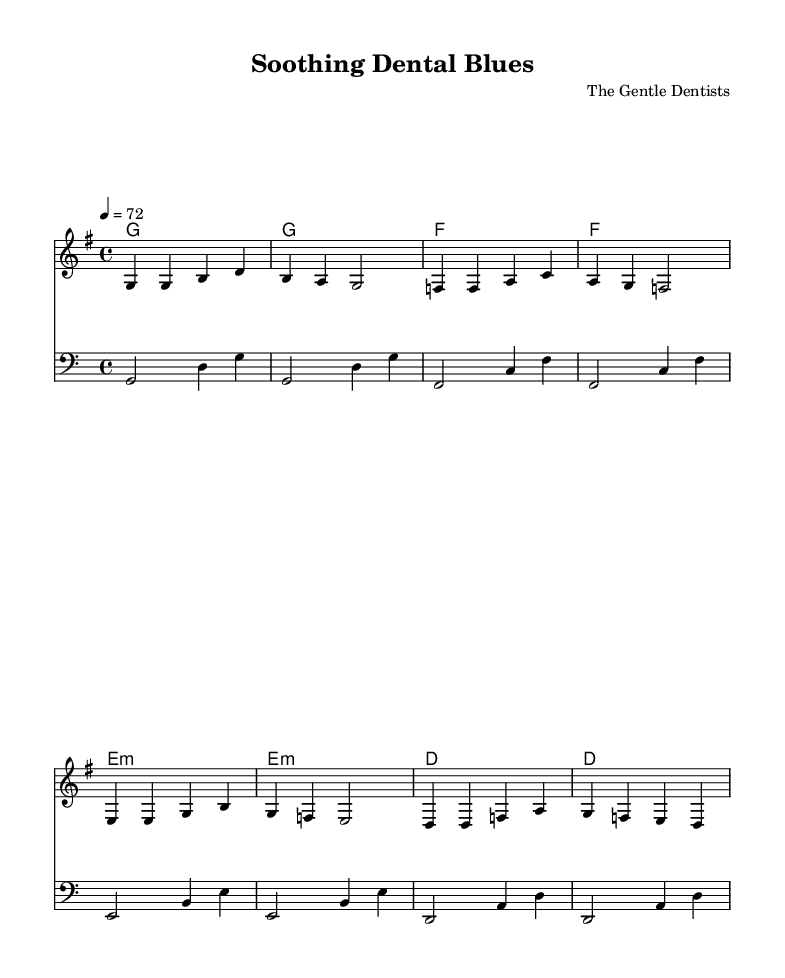What is the key signature of this music? The key signature is G major, which has one sharp, F#. This can be identified by looking at the key signature indication at the beginning of the staff.
Answer: G major What is the time signature of this music? The time signature is 4/4, recognized by the notation at the beginning of the score that indicates four beats per measure, with the quarter note receiving one beat.
Answer: 4/4 What is the tempo marking in this piece? The tempo marking is 72 BPM, stated at the beginning of the score above the staff, which indicates the beats per minute.
Answer: 72 How many measures are in the melody? The melody consists of 8 measures, which can be counted by looking at the bars between the double lines that indicate the end of each measure.
Answer: 8 What is the first chord in the harmonies? The first chord in the harmonies is G, identified by the chord notation written above the staff at the start of the piece.
Answer: G What is the main theme of the lyrics? The lyrics convey a message of comfort and reassurance while visiting the dentist, which can be inferred from the words describing relaxation and ease.
Answer: Comfort How do the bass line notes change in the progression? The bass line notes follow a descending progression from G to D to F to E to D, with each note reflecting the corresponding harmony below it. This is typical in R&B to create a groove.
Answer: Descending 